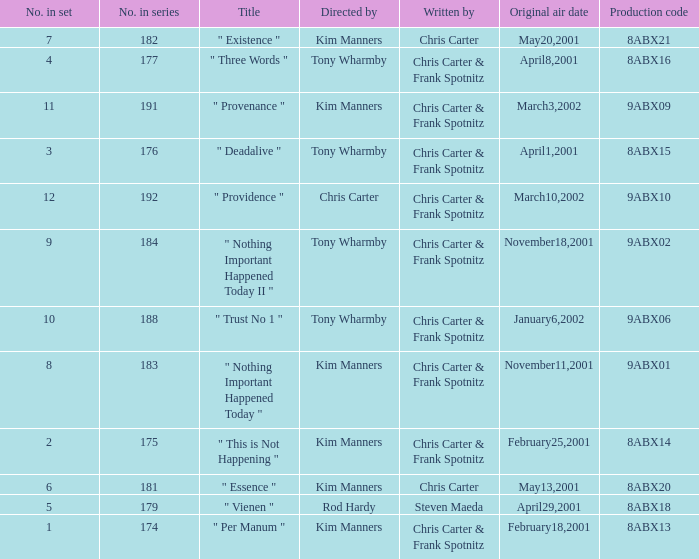The episode with production code 9abx02 was originally aired on what date? November18,2001. 